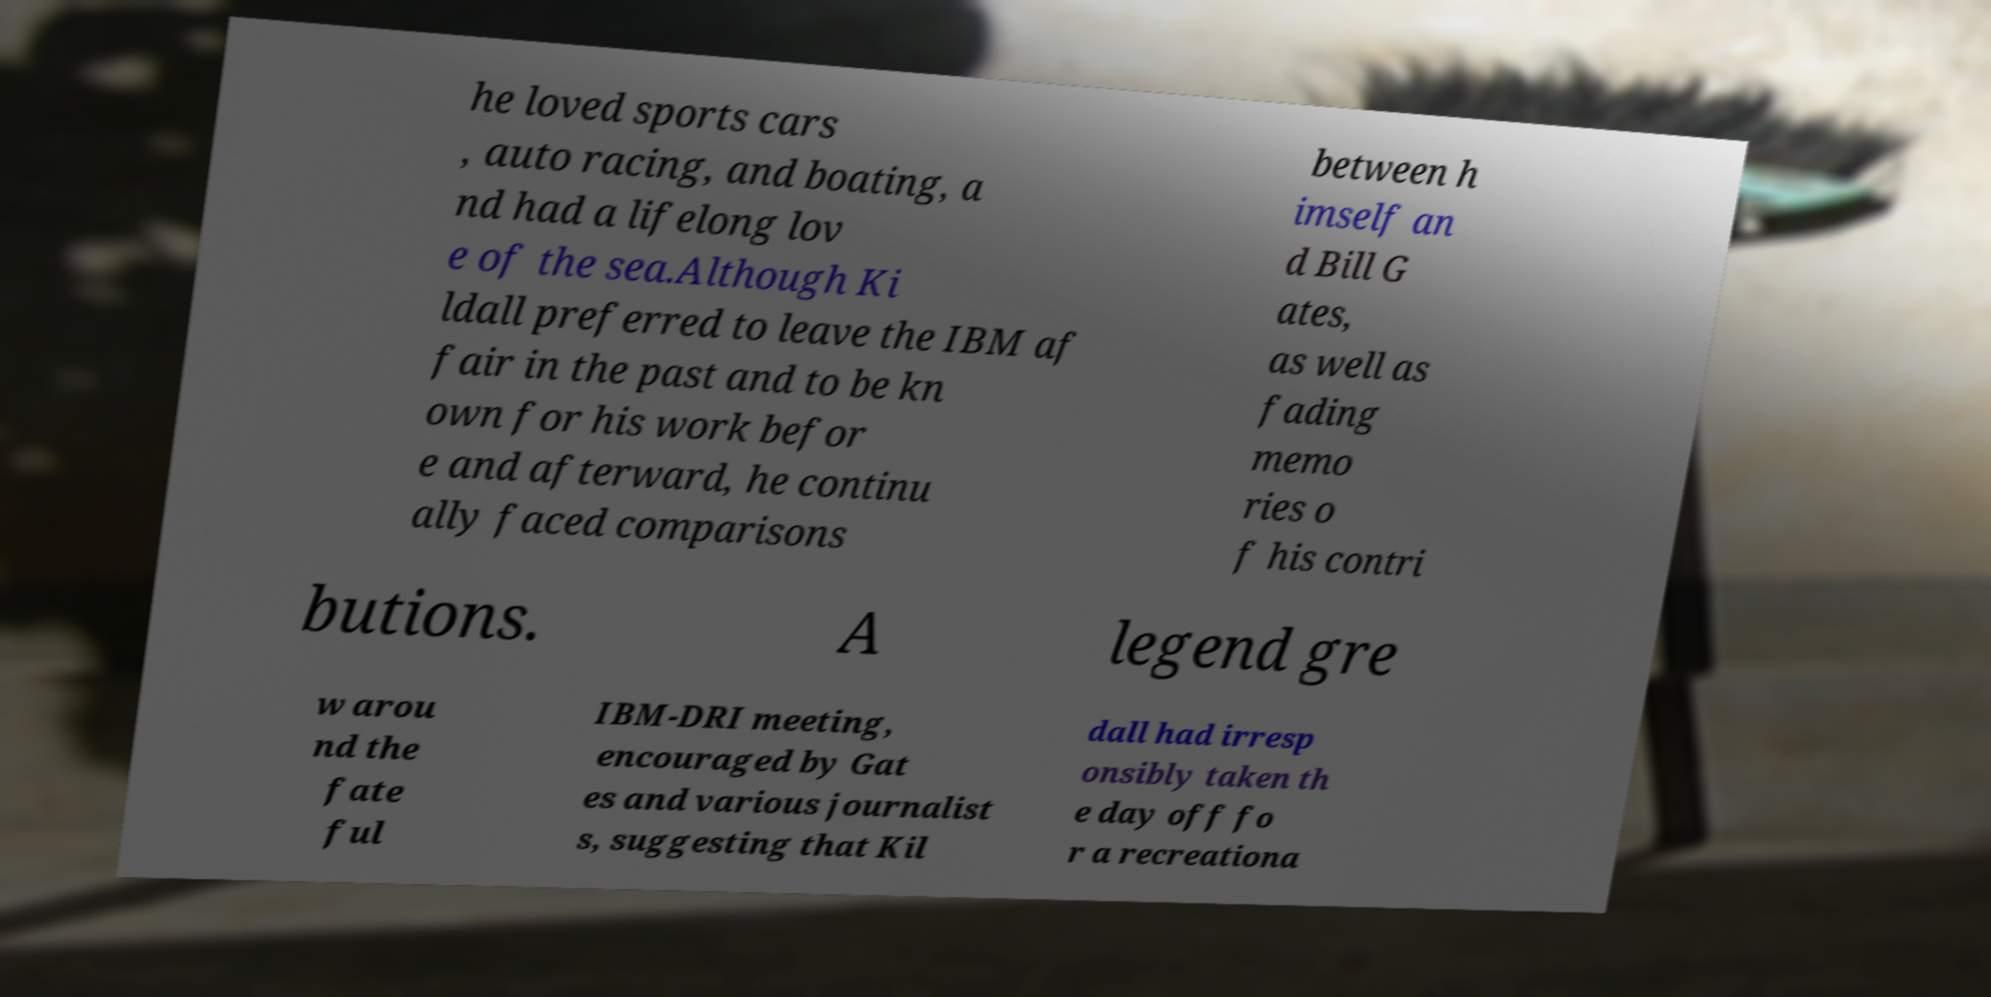What messages or text are displayed in this image? I need them in a readable, typed format. he loved sports cars , auto racing, and boating, a nd had a lifelong lov e of the sea.Although Ki ldall preferred to leave the IBM af fair in the past and to be kn own for his work befor e and afterward, he continu ally faced comparisons between h imself an d Bill G ates, as well as fading memo ries o f his contri butions. A legend gre w arou nd the fate ful IBM-DRI meeting, encouraged by Gat es and various journalist s, suggesting that Kil dall had irresp onsibly taken th e day off fo r a recreationa 